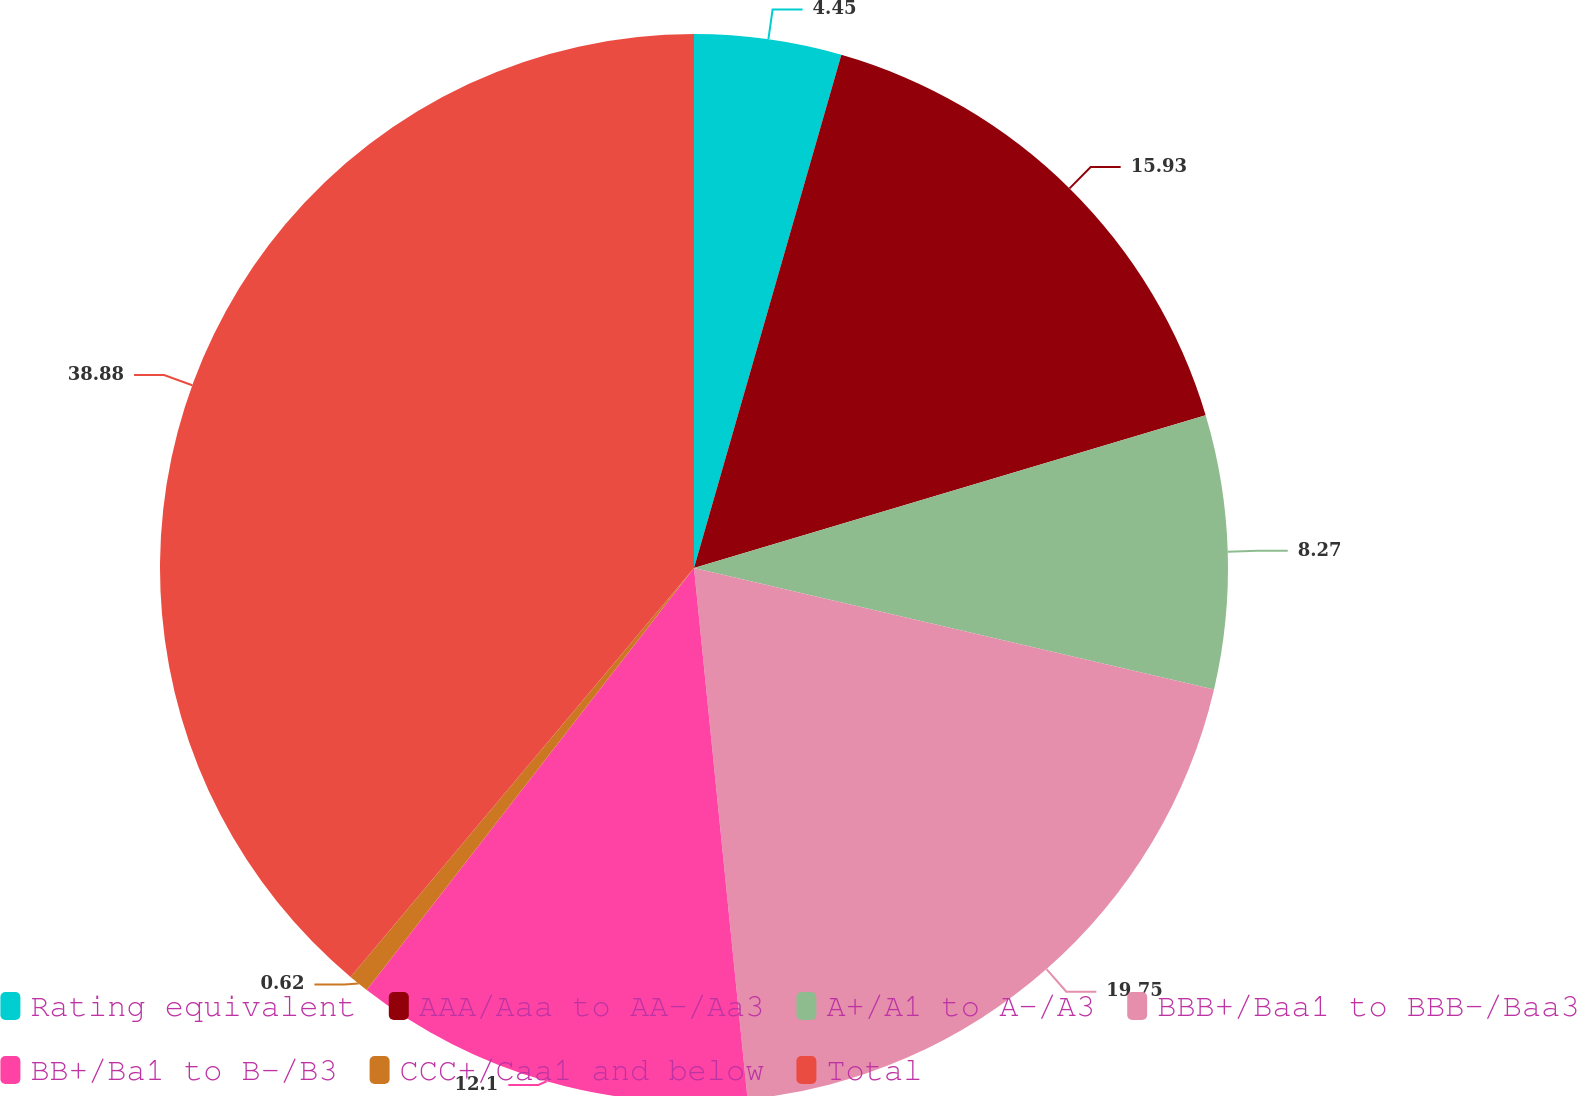<chart> <loc_0><loc_0><loc_500><loc_500><pie_chart><fcel>Rating equivalent<fcel>AAA/Aaa to AA-/Aa3<fcel>A+/A1 to A-/A3<fcel>BBB+/Baa1 to BBB-/Baa3<fcel>BB+/Ba1 to B-/B3<fcel>CCC+/Caa1 and below<fcel>Total<nl><fcel>4.45%<fcel>15.93%<fcel>8.27%<fcel>19.75%<fcel>12.1%<fcel>0.62%<fcel>38.88%<nl></chart> 